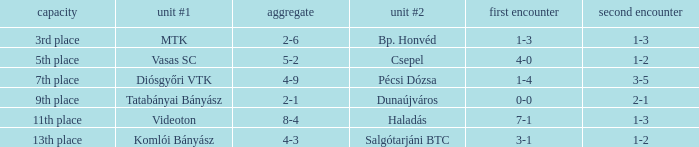How many positions correspond to a 1-3 1st leg? 1.0. 